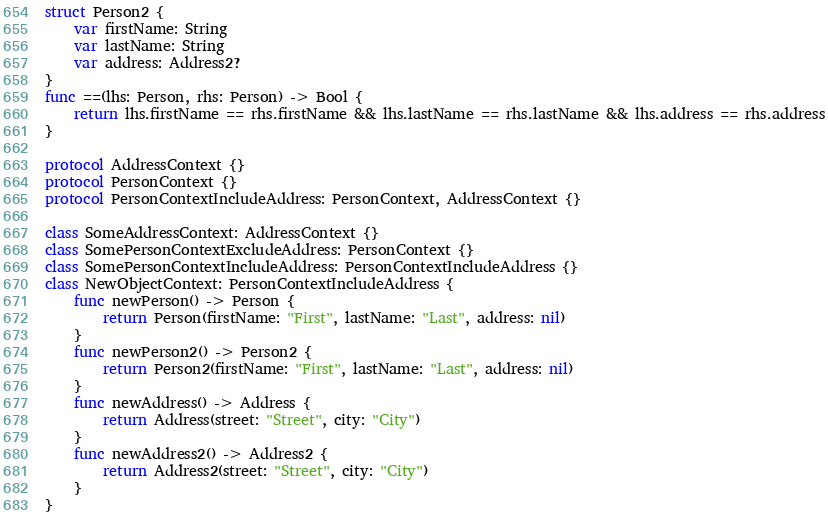Convert code to text. <code><loc_0><loc_0><loc_500><loc_500><_Swift_>struct Person2 {
    var firstName: String
    var lastName: String
    var address: Address2?
}
func ==(lhs: Person, rhs: Person) -> Bool {
    return lhs.firstName == rhs.firstName && lhs.lastName == rhs.lastName && lhs.address == rhs.address
}

protocol AddressContext {}
protocol PersonContext {}
protocol PersonContextIncludeAddress: PersonContext, AddressContext {}

class SomeAddressContext: AddressContext {}
class SomePersonContextExcludeAddress: PersonContext {}
class SomePersonContextIncludeAddress: PersonContextIncludeAddress {}
class NewObjectContext: PersonContextIncludeAddress {
    func newPerson() -> Person {
        return Person(firstName: "First", lastName: "Last", address: nil)
    }
    func newPerson2() -> Person2 {
        return Person2(firstName: "First", lastName: "Last", address: nil)
    }
    func newAddress() -> Address {
        return Address(street: "Street", city: "City")
    }
    func newAddress2() -> Address2 {
        return Address2(street: "Street", city: "City")
    }
}
</code> 